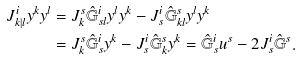Convert formula to latex. <formula><loc_0><loc_0><loc_500><loc_500>J ^ { i } _ { k | l } y ^ { k } y ^ { l } & = J ^ { s } _ { k } \hat { \mathbb { G } } ^ { i } _ { s l } y ^ { l } y ^ { k } - J ^ { i } _ { s } \hat { \mathbb { G } } ^ { s } _ { k l } y ^ { l } y ^ { k } \\ & = J ^ { s } _ { k } \hat { \mathbb { G } } ^ { i } _ { s } y ^ { k } - J ^ { i } _ { s } \hat { \mathbb { G } } ^ { s } _ { k } y ^ { k } = \hat { \mathbb { G } } ^ { i } _ { s } u ^ { s } - 2 J ^ { i } _ { s } \hat { \mathbb { G } } ^ { s } .</formula> 